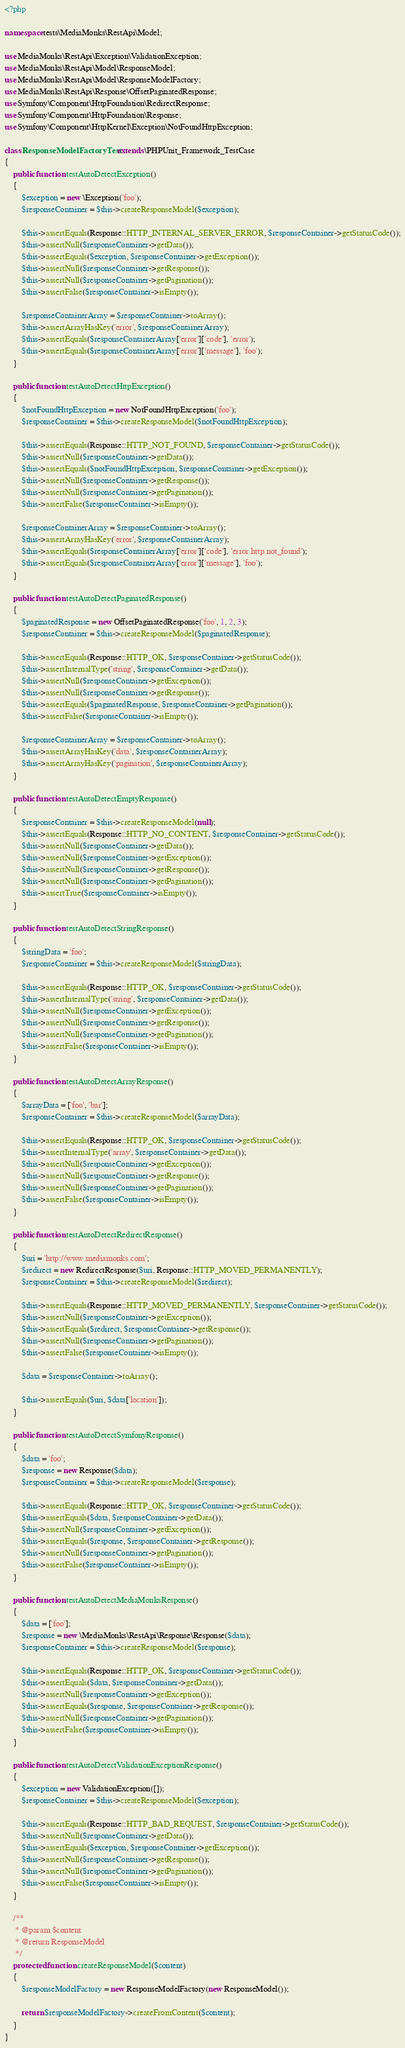<code> <loc_0><loc_0><loc_500><loc_500><_PHP_><?php

namespace tests\MediaMonks\RestApi\Model;

use MediaMonks\RestApi\Exception\ValidationException;
use MediaMonks\RestApi\Model\ResponseModel;
use MediaMonks\RestApi\Model\ResponseModelFactory;
use MediaMonks\RestApi\Response\OffsetPaginatedResponse;
use Symfony\Component\HttpFoundation\RedirectResponse;
use Symfony\Component\HttpFoundation\Response;
use Symfony\Component\HttpKernel\Exception\NotFoundHttpException;

class ResponseModelFactoryTest extends \PHPUnit_Framework_TestCase
{
    public function testAutoDetectException()
    {
        $exception = new \Exception('foo');
        $responseContainer = $this->createResponseModel($exception);

        $this->assertEquals(Response::HTTP_INTERNAL_SERVER_ERROR, $responseContainer->getStatusCode());
        $this->assertNull($responseContainer->getData());
        $this->assertEquals($exception, $responseContainer->getException());
        $this->assertNull($responseContainer->getResponse());
        $this->assertNull($responseContainer->getPagination());
        $this->assertFalse($responseContainer->isEmpty());

        $responseContainerArray = $responseContainer->toArray();
        $this->assertArrayHasKey('error', $responseContainerArray);
        $this->assertEquals($responseContainerArray['error']['code'], 'error');
        $this->assertEquals($responseContainerArray['error']['message'], 'foo');
    }

    public function testAutoDetectHttpException()
    {
        $notFoundHttpException = new NotFoundHttpException('foo');
        $responseContainer = $this->createResponseModel($notFoundHttpException);

        $this->assertEquals(Response::HTTP_NOT_FOUND, $responseContainer->getStatusCode());
        $this->assertNull($responseContainer->getData());
        $this->assertEquals($notFoundHttpException, $responseContainer->getException());
        $this->assertNull($responseContainer->getResponse());
        $this->assertNull($responseContainer->getPagination());
        $this->assertFalse($responseContainer->isEmpty());

        $responseContainerArray = $responseContainer->toArray();
        $this->assertArrayHasKey('error', $responseContainerArray);
        $this->assertEquals($responseContainerArray['error']['code'], 'error.http.not_found');
        $this->assertEquals($responseContainerArray['error']['message'], 'foo');
    }

    public function testAutoDetectPaginatedResponse()
    {
        $paginatedResponse = new OffsetPaginatedResponse('foo', 1, 2, 3);
        $responseContainer = $this->createResponseModel($paginatedResponse);

        $this->assertEquals(Response::HTTP_OK, $responseContainer->getStatusCode());
        $this->assertInternalType('string', $responseContainer->getData());
        $this->assertNull($responseContainer->getException());
        $this->assertNull($responseContainer->getResponse());
        $this->assertEquals($paginatedResponse, $responseContainer->getPagination());
        $this->assertFalse($responseContainer->isEmpty());

        $responseContainerArray = $responseContainer->toArray();
        $this->assertArrayHasKey('data', $responseContainerArray);
        $this->assertArrayHasKey('pagination', $responseContainerArray);
    }

    public function testAutoDetectEmptyResponse()
    {
        $responseContainer = $this->createResponseModel(null);
        $this->assertEquals(Response::HTTP_NO_CONTENT, $responseContainer->getStatusCode());
        $this->assertNull($responseContainer->getData());
        $this->assertNull($responseContainer->getException());
        $this->assertNull($responseContainer->getResponse());
        $this->assertNull($responseContainer->getPagination());
        $this->assertTrue($responseContainer->isEmpty());
    }

    public function testAutoDetectStringResponse()
    {
        $stringData = 'foo';
        $responseContainer = $this->createResponseModel($stringData);

        $this->assertEquals(Response::HTTP_OK, $responseContainer->getStatusCode());
        $this->assertInternalType('string', $responseContainer->getData());
        $this->assertNull($responseContainer->getException());
        $this->assertNull($responseContainer->getResponse());
        $this->assertNull($responseContainer->getPagination());
        $this->assertFalse($responseContainer->isEmpty());
    }

    public function testAutoDetectArrayResponse()
    {
        $arrayData = ['foo', 'bar'];
        $responseContainer = $this->createResponseModel($arrayData);

        $this->assertEquals(Response::HTTP_OK, $responseContainer->getStatusCode());
        $this->assertInternalType('array', $responseContainer->getData());
        $this->assertNull($responseContainer->getException());
        $this->assertNull($responseContainer->getResponse());
        $this->assertNull($responseContainer->getPagination());
        $this->assertFalse($responseContainer->isEmpty());
    }

    public function testAutoDetectRedirectResponse()
    {
        $uri = 'http://www.mediamonks.com';
        $redirect = new RedirectResponse($uri, Response::HTTP_MOVED_PERMANENTLY);
        $responseContainer = $this->createResponseModel($redirect);

        $this->assertEquals(Response::HTTP_MOVED_PERMANENTLY, $responseContainer->getStatusCode());
        $this->assertNull($responseContainer->getException());
        $this->assertEquals($redirect, $responseContainer->getResponse());
        $this->assertNull($responseContainer->getPagination());
        $this->assertFalse($responseContainer->isEmpty());

        $data = $responseContainer->toArray();

        $this->assertEquals($uri, $data['location']);
    }

    public function testAutoDetectSymfonyResponse()
    {
        $data = 'foo';
        $response = new Response($data);
        $responseContainer = $this->createResponseModel($response);

        $this->assertEquals(Response::HTTP_OK, $responseContainer->getStatusCode());
        $this->assertEquals($data, $responseContainer->getData());
        $this->assertNull($responseContainer->getException());
        $this->assertEquals($response, $responseContainer->getResponse());
        $this->assertNull($responseContainer->getPagination());
        $this->assertFalse($responseContainer->isEmpty());
    }

    public function testAutoDetectMediaMonksResponse()
    {
        $data = ['foo'];
        $response = new \MediaMonks\RestApi\Response\Response($data);
        $responseContainer = $this->createResponseModel($response);

        $this->assertEquals(Response::HTTP_OK, $responseContainer->getStatusCode());
        $this->assertEquals($data, $responseContainer->getData());
        $this->assertNull($responseContainer->getException());
        $this->assertEquals($response, $responseContainer->getResponse());
        $this->assertNull($responseContainer->getPagination());
        $this->assertFalse($responseContainer->isEmpty());
    }

    public function testAutoDetectValidationExceptionResponse()
    {
        $exception = new ValidationException([]);
        $responseContainer = $this->createResponseModel($exception);

        $this->assertEquals(Response::HTTP_BAD_REQUEST, $responseContainer->getStatusCode());
        $this->assertNull($responseContainer->getData());
        $this->assertEquals($exception, $responseContainer->getException());
        $this->assertNull($responseContainer->getResponse());
        $this->assertNull($responseContainer->getPagination());
        $this->assertFalse($responseContainer->isEmpty());
    }

    /**
     * @param $content
     * @return ResponseModel
     */
    protected function createResponseModel($content)
    {
        $responseModelFactory = new ResponseModelFactory(new ResponseModel());

        return $responseModelFactory->createFromContent($content);
    }
}
</code> 